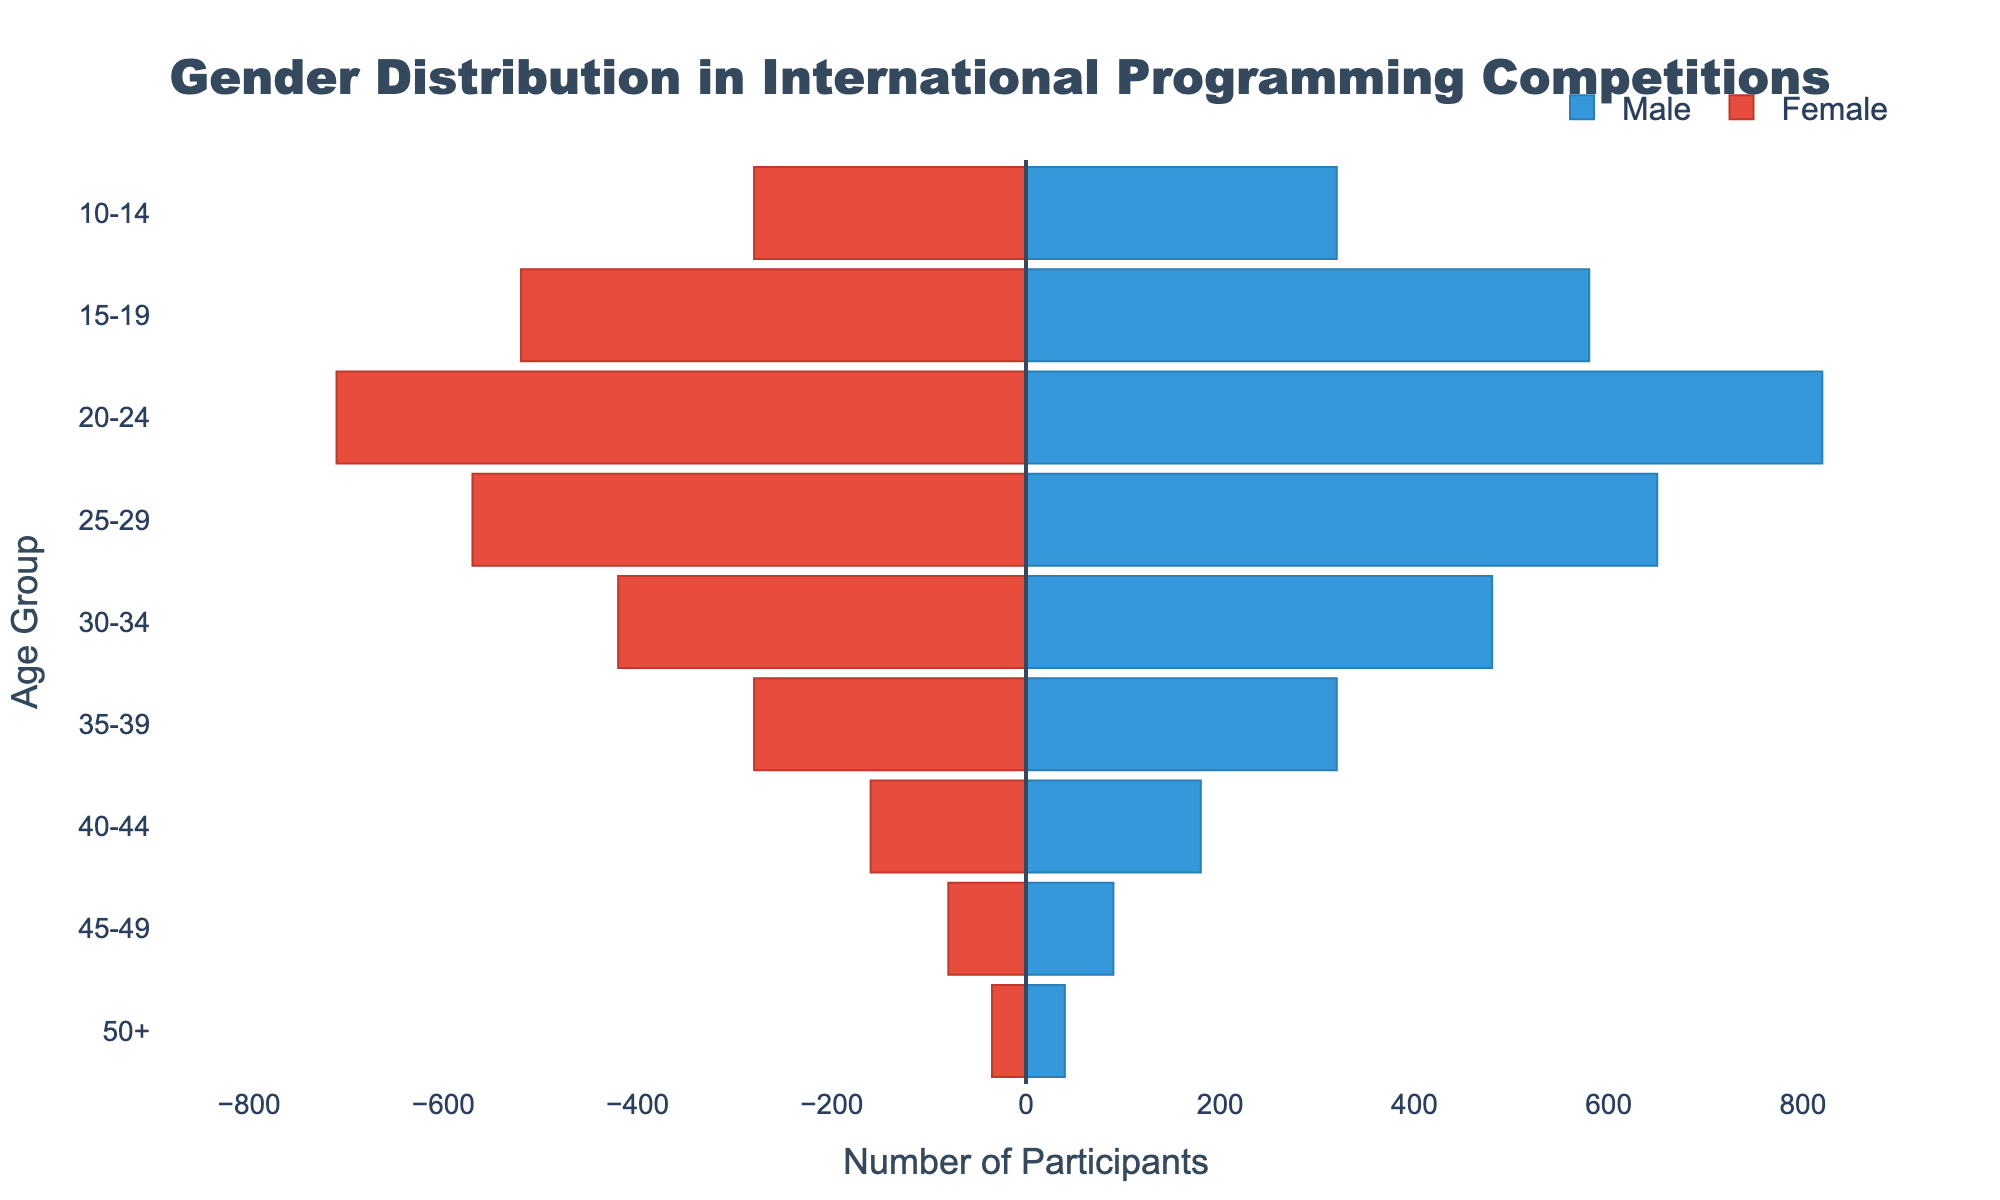What is the title of the figure? The title can be found at the top of the figure. It is often displayed prominently in larger font size.
Answer: Gender Distribution in International Programming Competitions How many age groups are identified in the figure? Count the number of distinct age groups along the y-axis.
Answer: 9 Which age group has the highest number of male participants? Look for the longest bar on the male side (right side of the figure) and identify the corresponding age group.
Answer: 20-24 By how much does the number of female participants in the 20-24 age group differ from the 15-19 age group? Determine the values for female participants in both age groups and calculate the difference (710 - 520 = 190).
Answer: 190 What is the total number of participants in the 10-14 age group? Sum the absolute values of male and female participants in the 10-14 age group (320 + 280 = 600).
Answer: 600 Which age group has the smallest difference between male and female participants? Calculate the absolute difference between male and female participants for each age group, then identify the smallest difference. For the 50+ group:
Answer: 5 What is the overall trend in participant numbers as age increases? Observe the lengths of the bars to notice how the numbers change from the youngest to the oldest age groups.
Answer: Decreasing Which age group has the closest to equal number of male and female participants? Look for age groups with the most similar bar lengths on both sides. Compare their lengths visually to find the closest match.
Answer: 50+ How many more male participants are there compared to female participants in the 25-29 age group? Find the number of male and female participants in this age group and compute the difference (650 - 570 = 80).
Answer: 80 Are there more male or female participants in the 40-44 age group? Compare the lengths of the male and female bars in the 40-44 age group.
Answer: Male 